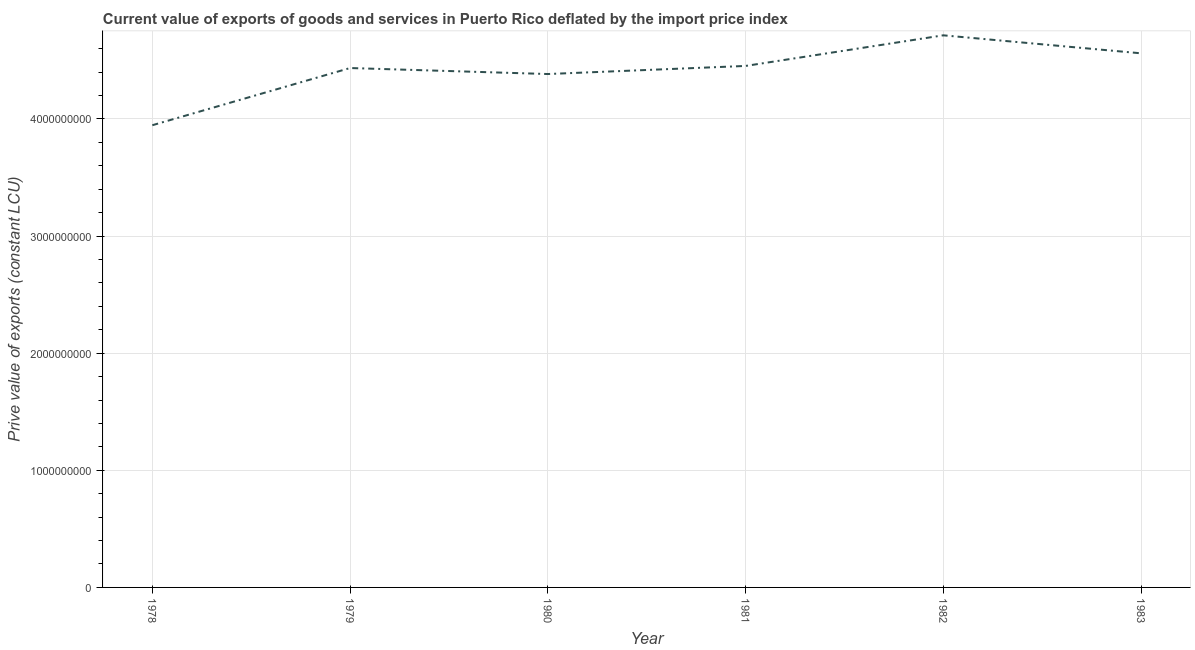What is the price value of exports in 1979?
Keep it short and to the point. 4.43e+09. Across all years, what is the maximum price value of exports?
Ensure brevity in your answer.  4.71e+09. Across all years, what is the minimum price value of exports?
Offer a very short reply. 3.95e+09. In which year was the price value of exports maximum?
Make the answer very short. 1982. In which year was the price value of exports minimum?
Provide a short and direct response. 1978. What is the sum of the price value of exports?
Offer a very short reply. 2.65e+1. What is the difference between the price value of exports in 1978 and 1980?
Provide a short and direct response. -4.37e+08. What is the average price value of exports per year?
Offer a terse response. 4.41e+09. What is the median price value of exports?
Your answer should be compact. 4.44e+09. In how many years, is the price value of exports greater than 2600000000 LCU?
Offer a terse response. 6. What is the ratio of the price value of exports in 1978 to that in 1983?
Keep it short and to the point. 0.87. Is the price value of exports in 1979 less than that in 1982?
Provide a short and direct response. Yes. What is the difference between the highest and the second highest price value of exports?
Your answer should be very brief. 1.54e+08. Is the sum of the price value of exports in 1981 and 1983 greater than the maximum price value of exports across all years?
Your answer should be compact. Yes. What is the difference between the highest and the lowest price value of exports?
Provide a succinct answer. 7.67e+08. In how many years, is the price value of exports greater than the average price value of exports taken over all years?
Offer a terse response. 4. How many lines are there?
Provide a succinct answer. 1. What is the difference between two consecutive major ticks on the Y-axis?
Ensure brevity in your answer.  1.00e+09. Are the values on the major ticks of Y-axis written in scientific E-notation?
Offer a terse response. No. Does the graph contain grids?
Offer a very short reply. Yes. What is the title of the graph?
Provide a short and direct response. Current value of exports of goods and services in Puerto Rico deflated by the import price index. What is the label or title of the X-axis?
Give a very brief answer. Year. What is the label or title of the Y-axis?
Provide a succinct answer. Prive value of exports (constant LCU). What is the Prive value of exports (constant LCU) of 1978?
Keep it short and to the point. 3.95e+09. What is the Prive value of exports (constant LCU) of 1979?
Offer a very short reply. 4.43e+09. What is the Prive value of exports (constant LCU) of 1980?
Provide a short and direct response. 4.38e+09. What is the Prive value of exports (constant LCU) in 1981?
Keep it short and to the point. 4.45e+09. What is the Prive value of exports (constant LCU) of 1982?
Your answer should be compact. 4.71e+09. What is the Prive value of exports (constant LCU) in 1983?
Make the answer very short. 4.56e+09. What is the difference between the Prive value of exports (constant LCU) in 1978 and 1979?
Your response must be concise. -4.88e+08. What is the difference between the Prive value of exports (constant LCU) in 1978 and 1980?
Provide a succinct answer. -4.37e+08. What is the difference between the Prive value of exports (constant LCU) in 1978 and 1981?
Give a very brief answer. -5.06e+08. What is the difference between the Prive value of exports (constant LCU) in 1978 and 1982?
Make the answer very short. -7.67e+08. What is the difference between the Prive value of exports (constant LCU) in 1978 and 1983?
Your answer should be compact. -6.14e+08. What is the difference between the Prive value of exports (constant LCU) in 1979 and 1980?
Your answer should be compact. 5.12e+07. What is the difference between the Prive value of exports (constant LCU) in 1979 and 1981?
Provide a short and direct response. -1.79e+07. What is the difference between the Prive value of exports (constant LCU) in 1979 and 1982?
Your response must be concise. -2.79e+08. What is the difference between the Prive value of exports (constant LCU) in 1979 and 1983?
Make the answer very short. -1.26e+08. What is the difference between the Prive value of exports (constant LCU) in 1980 and 1981?
Your response must be concise. -6.91e+07. What is the difference between the Prive value of exports (constant LCU) in 1980 and 1982?
Keep it short and to the point. -3.30e+08. What is the difference between the Prive value of exports (constant LCU) in 1980 and 1983?
Make the answer very short. -1.77e+08. What is the difference between the Prive value of exports (constant LCU) in 1981 and 1982?
Make the answer very short. -2.61e+08. What is the difference between the Prive value of exports (constant LCU) in 1981 and 1983?
Provide a short and direct response. -1.08e+08. What is the difference between the Prive value of exports (constant LCU) in 1982 and 1983?
Provide a succinct answer. 1.54e+08. What is the ratio of the Prive value of exports (constant LCU) in 1978 to that in 1979?
Offer a very short reply. 0.89. What is the ratio of the Prive value of exports (constant LCU) in 1978 to that in 1981?
Provide a succinct answer. 0.89. What is the ratio of the Prive value of exports (constant LCU) in 1978 to that in 1982?
Ensure brevity in your answer.  0.84. What is the ratio of the Prive value of exports (constant LCU) in 1978 to that in 1983?
Your response must be concise. 0.86. What is the ratio of the Prive value of exports (constant LCU) in 1979 to that in 1980?
Your response must be concise. 1.01. What is the ratio of the Prive value of exports (constant LCU) in 1979 to that in 1982?
Provide a succinct answer. 0.94. What is the ratio of the Prive value of exports (constant LCU) in 1979 to that in 1983?
Your answer should be very brief. 0.97. What is the ratio of the Prive value of exports (constant LCU) in 1980 to that in 1981?
Provide a short and direct response. 0.98. What is the ratio of the Prive value of exports (constant LCU) in 1980 to that in 1982?
Your response must be concise. 0.93. What is the ratio of the Prive value of exports (constant LCU) in 1981 to that in 1982?
Offer a very short reply. 0.94. What is the ratio of the Prive value of exports (constant LCU) in 1981 to that in 1983?
Your answer should be very brief. 0.98. What is the ratio of the Prive value of exports (constant LCU) in 1982 to that in 1983?
Offer a terse response. 1.03. 